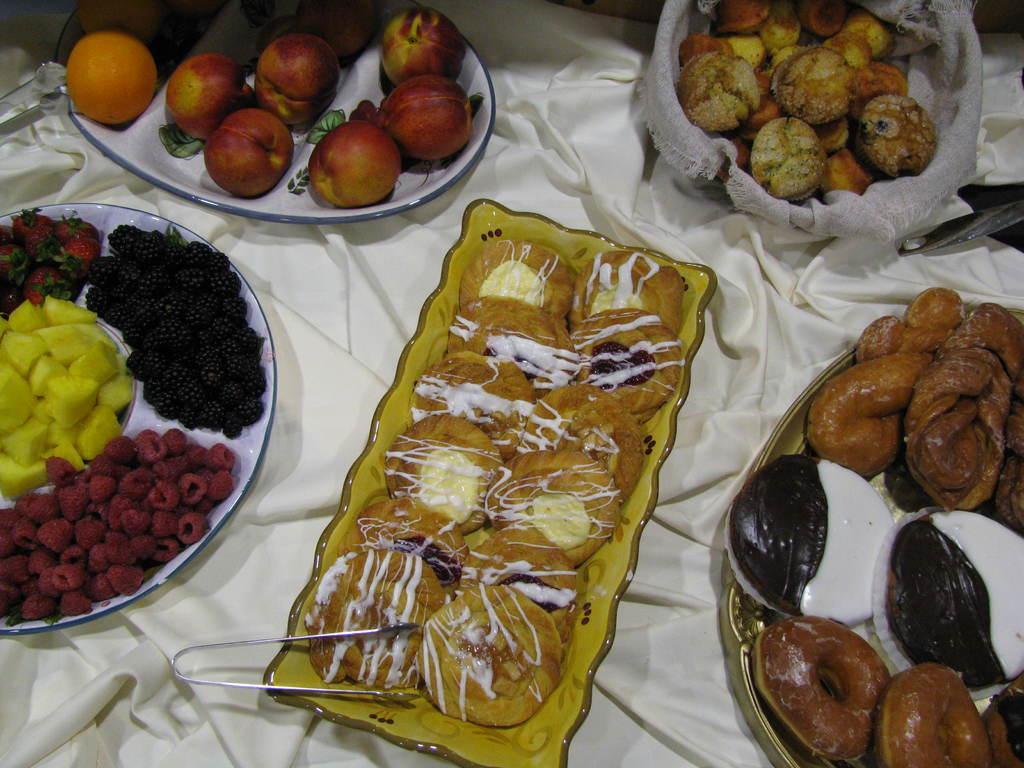Describe this image in one or two sentences. This image consists of eatable items which are on the plates, on the table and there metal objects which are visible. 